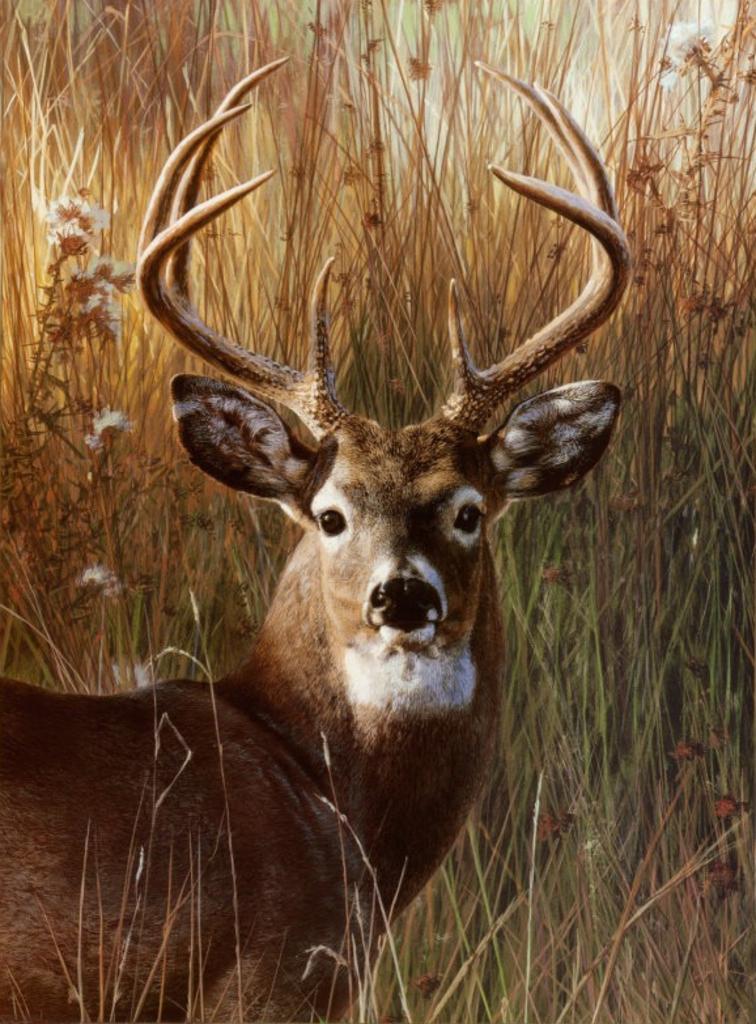Can you describe this image briefly? In this image we can see a deer with horns on its head is standing on the ground. In the background we can see group of plants. 